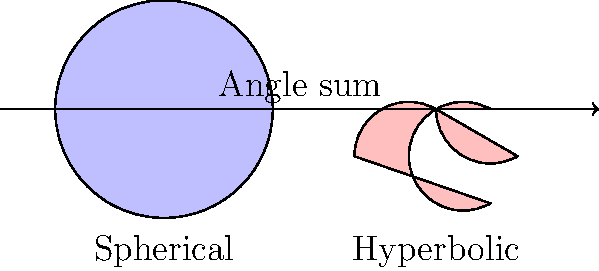In the context of Non-Euclidean Geometry, consider the comparison of triangle angle sums in spherical and hyperbolic geometries. If a triangle in spherical geometry has an angle sum of $270^\circ$, what would be the approximate angle sum of a similar-sized triangle in hyperbolic geometry? To answer this question, let's break it down step-by-step:

1. In Euclidean geometry, the sum of angles in a triangle is always $180^\circ$.

2. Spherical geometry:
   - The sum of angles in a spherical triangle is always greater than $180^\circ$.
   - The formula for the angle sum in a spherical triangle is: $\alpha + \beta + \gamma - 180^\circ = A/R^2$
     Where $\alpha$, $\beta$, and $\gamma$ are the angles, $A$ is the area of the triangle, and $R$ is the radius of the sphere.
   - In this case, we're given that the angle sum is $270^\circ$, which is $90^\circ$ more than in Euclidean geometry.

3. Hyperbolic geometry:
   - The sum of angles in a hyperbolic triangle is always less than $180^\circ$.
   - The formula for the angle sum in a hyperbolic triangle is: $180^\circ - (\alpha + \beta + \gamma) = A/R^2$
     Where $\alpha$, $\beta$, and $\gamma$ are the angles, $A$ is the area of the triangle, and $R$ is the radius of curvature.

4. The relationship between spherical and hyperbolic geometries:
   - They are in some sense "opposite" to each other with respect to Euclidean geometry.
   - The deviation from $180^\circ$ in spherical geometry is approximately equal in magnitude but opposite in direction to the deviation in hyperbolic geometry for similar-sized triangles.

5. Given that the spherical triangle has an angle sum of $270^\circ$, which is $90^\circ$ more than Euclidean:
   - We can expect the hyperbolic triangle to have an angle sum that is approximately $90^\circ$ less than Euclidean.
   - Therefore, the approximate angle sum in hyperbolic geometry would be: $180^\circ - 90^\circ = 90^\circ$

This approximation assumes that the triangles are of similar size and that the curvature of the spaces is comparable in magnitude.
Answer: Approximately $90^\circ$ 